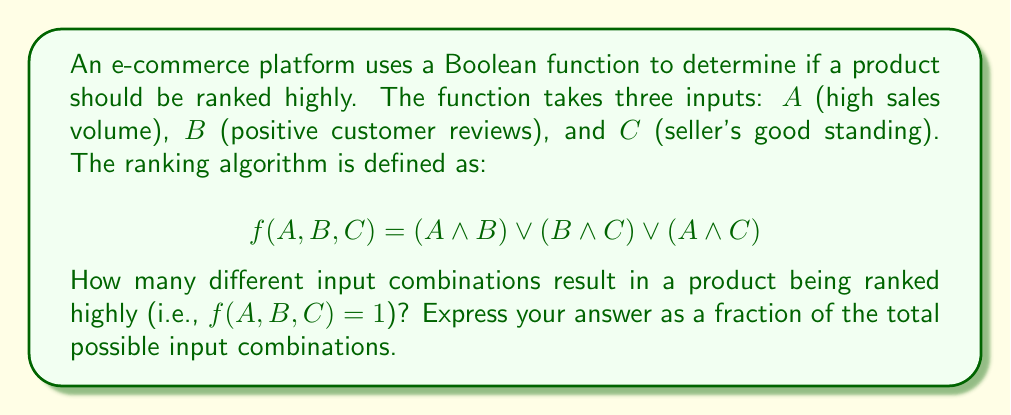Show me your answer to this math problem. Let's approach this step-by-step:

1) First, we need to determine the total number of possible input combinations. With 3 Boolean inputs, we have $2^3 = 8$ total combinations.

2) Now, let's evaluate the function for each combination:

   $f(0,0,0) = (0 \land 0) \lor (0 \land 0) \lor (0 \land 0) = 0$
   $f(0,0,1) = (0 \land 0) \lor (0 \land 1) \lor (0 \land 1) = 0$
   $f(0,1,0) = (0 \land 1) \lor (1 \land 0) \lor (0 \land 0) = 0$
   $f(0,1,1) = (0 \land 1) \lor (1 \land 1) \lor (0 \land 1) = 1$
   $f(1,0,0) = (1 \land 0) \lor (0 \land 0) \lor (1 \land 0) = 0$
   $f(1,0,1) = (1 \land 0) \lor (0 \land 1) \lor (1 \land 1) = 1$
   $f(1,1,0) = (1 \land 1) \lor (1 \land 0) \lor (1 \land 0) = 1$
   $f(1,1,1) = (1 \land 1) \lor (1 \land 1) \lor (1 \land 1) = 1$

3) Counting the number of times $f(A,B,C) = 1$, we get 4 combinations.

4) Therefore, the fraction of input combinations resulting in a high ranking is $\frac{4}{8} = \frac{1}{2}$.
Answer: $\frac{1}{2}$ 